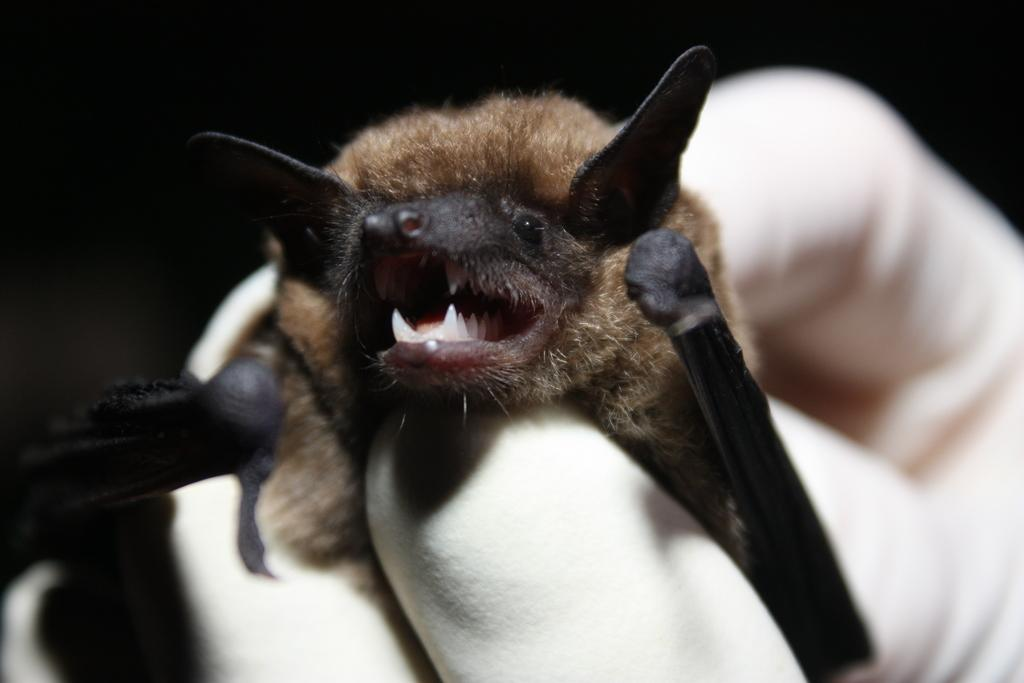What animal is present in the image? There is a bat in the image. How is the bat being held in the image? The bat is being held by a person. What is the color of the background in the image? The background of the image is dark. What type of home does the scarecrow live in within the image? There is no scarecrow or home present in the image; it features a bat being held by a person. What is the weight of the bat in the image? The weight of the bat cannot be determined from the image alone, as it does not provide information about the bat's size or physical characteristics. 